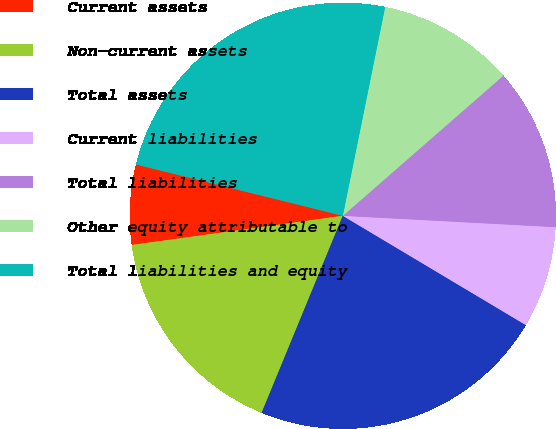Convert chart. <chart><loc_0><loc_0><loc_500><loc_500><pie_chart><fcel>Current assets<fcel>Non-current assets<fcel>Total assets<fcel>Current liabilities<fcel>Total liabilities<fcel>Other equity attributable to<fcel>Total liabilities and equity<nl><fcel>6.06%<fcel>16.59%<fcel>22.65%<fcel>7.72%<fcel>12.27%<fcel>10.39%<fcel>24.31%<nl></chart> 